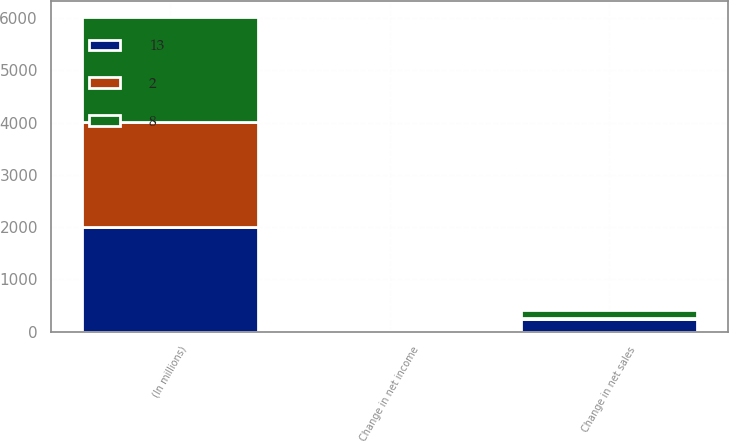Convert chart to OTSL. <chart><loc_0><loc_0><loc_500><loc_500><stacked_bar_chart><ecel><fcel>(In millions)<fcel>Change in net sales<fcel>Change in net income<nl><fcel>8<fcel>2008<fcel>168<fcel>8<nl><fcel>13<fcel>2007<fcel>232<fcel>13<nl><fcel>2<fcel>2006<fcel>21<fcel>2<nl></chart> 